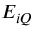<formula> <loc_0><loc_0><loc_500><loc_500>E _ { i Q }</formula> 